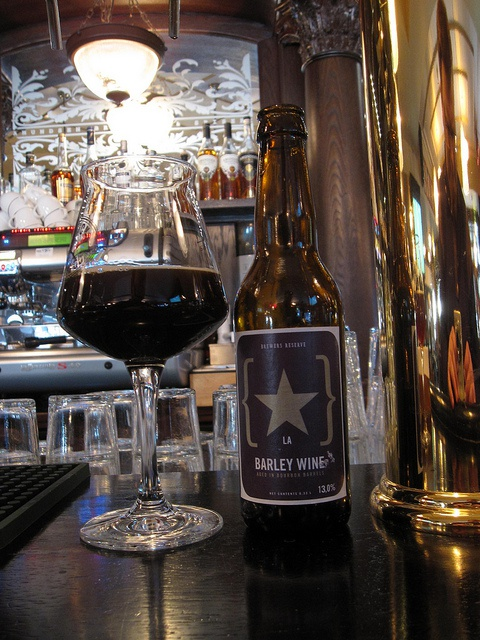Describe the objects in this image and their specific colors. I can see dining table in black, gray, and maroon tones, wine glass in black, gray, darkgray, and lightgray tones, bottle in black, maroon, and gray tones, bottle in black, maroon, and brown tones, and cup in black, gray, and darkgray tones in this image. 